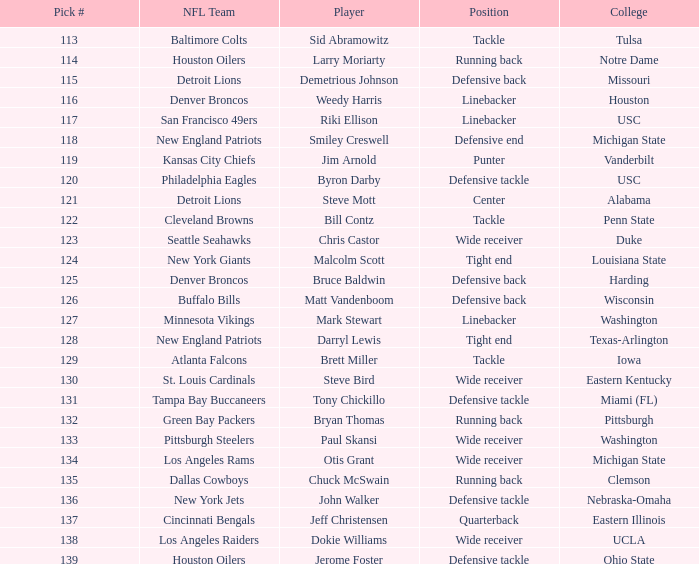What was bruce baldwin's pick #? 125.0. 